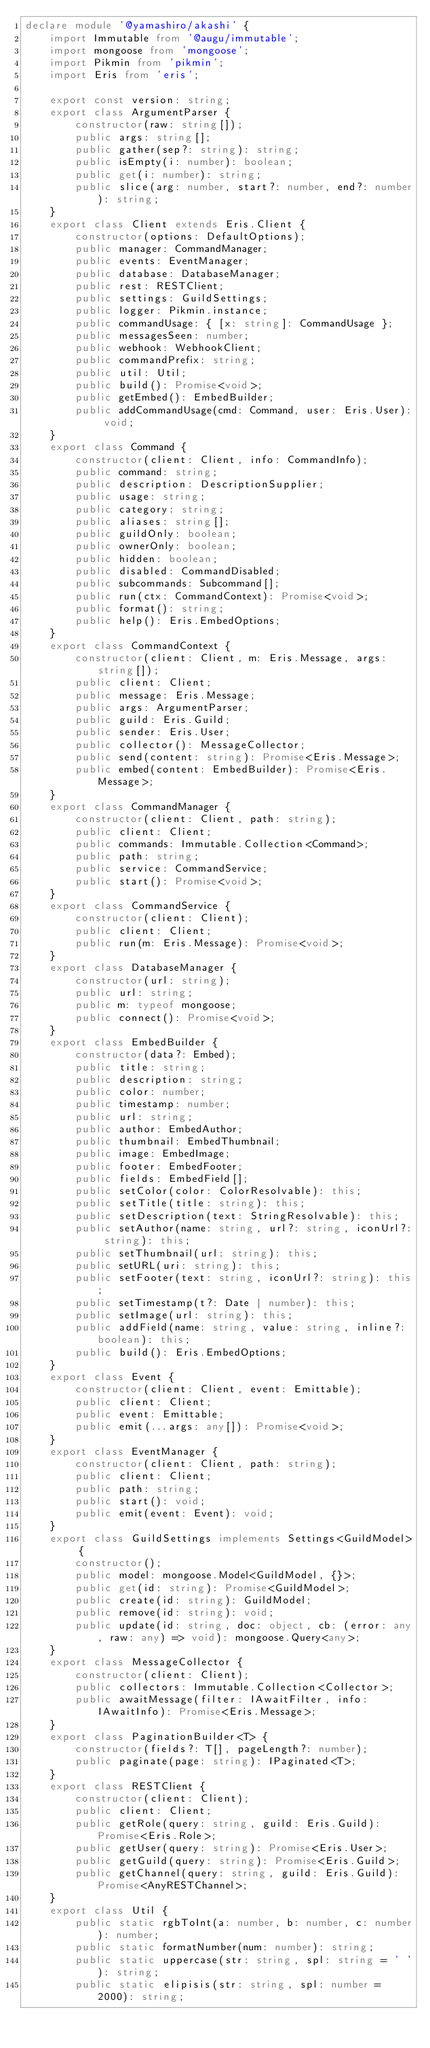<code> <loc_0><loc_0><loc_500><loc_500><_TypeScript_>declare module '@yamashiro/akashi' {
    import Immutable from '@augu/immutable';
    import mongoose from 'mongoose';
    import Pikmin from 'pikmin';
    import Eris from 'eris';

    export const version: string;
    export class ArgumentParser {
        constructor(raw: string[]);
        public args: string[];
        public gather(sep?: string): string;
        public isEmpty(i: number): boolean;
        public get(i: number): string;
        public slice(arg: number, start?: number, end?: number): string;
    }
    export class Client extends Eris.Client {
        constructor(options: DefaultOptions);
        public manager: CommandManager;
        public events: EventManager;
        public database: DatabaseManager;
        public rest: RESTClient;
        public settings: GuildSettings;
        public logger: Pikmin.instance;
        public commandUsage: { [x: string]: CommandUsage };
        public messagesSeen: number;
        public webhook: WebhookClient;
        public commandPrefix: string;
        public util: Util;
        public build(): Promise<void>;
        public getEmbed(): EmbedBuilder;
        public addCommandUsage(cmd: Command, user: Eris.User): void;
    }
    export class Command {
        constructor(client: Client, info: CommandInfo);
        public command: string;
        public description: DescriptionSupplier;
        public usage: string;
        public category: string;
        public aliases: string[];
        public guildOnly: boolean;
        public ownerOnly: boolean;
        public hidden: boolean;
        public disabled: CommandDisabled;
        public subcommands: Subcommand[];
        public run(ctx: CommandContext): Promise<void>;
        public format(): string;
        public help(): Eris.EmbedOptions;
    }
    export class CommandContext {
        constructor(client: Client, m: Eris.Message, args: string[]);
        public client: Client;
        public message: Eris.Message;
        public args: ArgumentParser;
        public guild: Eris.Guild;
        public sender: Eris.User;
        public collector(): MessageCollector;
        public send(content: string): Promise<Eris.Message>;
        public embed(content: EmbedBuilder): Promise<Eris.Message>;
    }
    export class CommandManager {
        constructor(client: Client, path: string);
        public client: Client;
        public commands: Immutable.Collection<Command>;
        public path: string;
        public service: CommandService;
        public start(): Promise<void>;
    }
    export class CommandService {
        constructor(client: Client);
        public client: Client;
        public run(m: Eris.Message): Promise<void>;
    }
    export class DatabaseManager {
        constructor(url: string);
        public url: string;
        public m: typeof mongoose;
        public connect(): Promise<void>;
    }
    export class EmbedBuilder {
        constructor(data?: Embed);
        public title: string;
        public description: string;
        public color: number;
        public timestamp: number;
        public url: string;
        public author: EmbedAuthor;
        public thumbnail: EmbedThumbnail;
        public image: EmbedImage;
        public footer: EmbedFooter;
        public fields: EmbedField[];
        public setColor(color: ColorResolvable): this;
        public setTitle(title: string): this;
        public setDescription(text: StringResolvable): this;
        public setAuthor(name: string, url?: string, iconUrl?: string): this;
        public setThumbnail(url: string): this;
        public setURL(uri: string): this;
        public setFooter(text: string, iconUrl?: string): this;
        public setTimestamp(t?: Date | number): this;
        public setImage(url: string): this;
        public addField(name: string, value: string, inline?: boolean): this;
        public build(): Eris.EmbedOptions;
    }
    export class Event {
        constructor(client: Client, event: Emittable);
        public client: Client;
        public event: Emittable;
        public emit(...args: any[]): Promise<void>;
    }
    export class EventManager {
        constructor(client: Client, path: string);
        public client: Client;
        public path: string;
        public start(): void;
        public emit(event: Event): void;
    }
    export class GuildSettings implements Settings<GuildModel> {
        constructor();
        public model: mongoose.Model<GuildModel, {}>;
        public get(id: string): Promise<GuildModel>;
        public create(id: string): GuildModel;
        public remove(id: string): void;
        public update(id: string, doc: object, cb: (error: any, raw: any) => void): mongoose.Query<any>;
    }
    export class MessageCollector {
        constructor(client: Client);
        public collectors: Immutable.Collection<Collector>;
        public awaitMessage(filter: IAwaitFilter, info: IAwaitInfo): Promise<Eris.Message>;
    }
    export class PaginationBuilder<T> {
        constructor(fields?: T[], pageLength?: number);
        public paginate(page: string): IPaginated<T>;
    }
    export class RESTClient {
        constructor(client: Client);
        public client: Client;
        public getRole(query: string, guild: Eris.Guild): Promise<Eris.Role>;
        public getUser(query: string): Promise<Eris.User>;
        public getGuild(query: string): Promise<Eris.Guild>;
        public getChannel(query: string, guild: Eris.Guild): Promise<AnyRESTChannel>;
    }
    export class Util {
        public static rgbToInt(a: number, b: number, c: number): number;
        public static formatNumber(num: number): string;
        public static uppercase(str: string, spl: string = ' '): string;
        public static elipisis(str: string, spl: number = 2000): string;</code> 